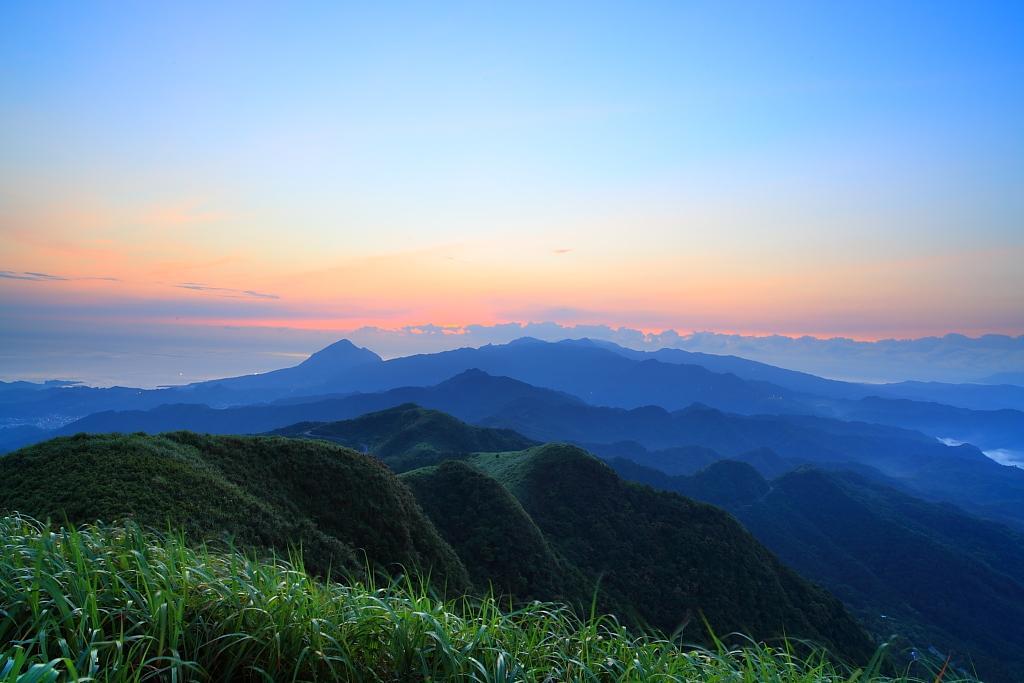Could you give a brief overview of what you see in this image? This image consists of mountains. There is grass at the bottom. There is sky at the top. 